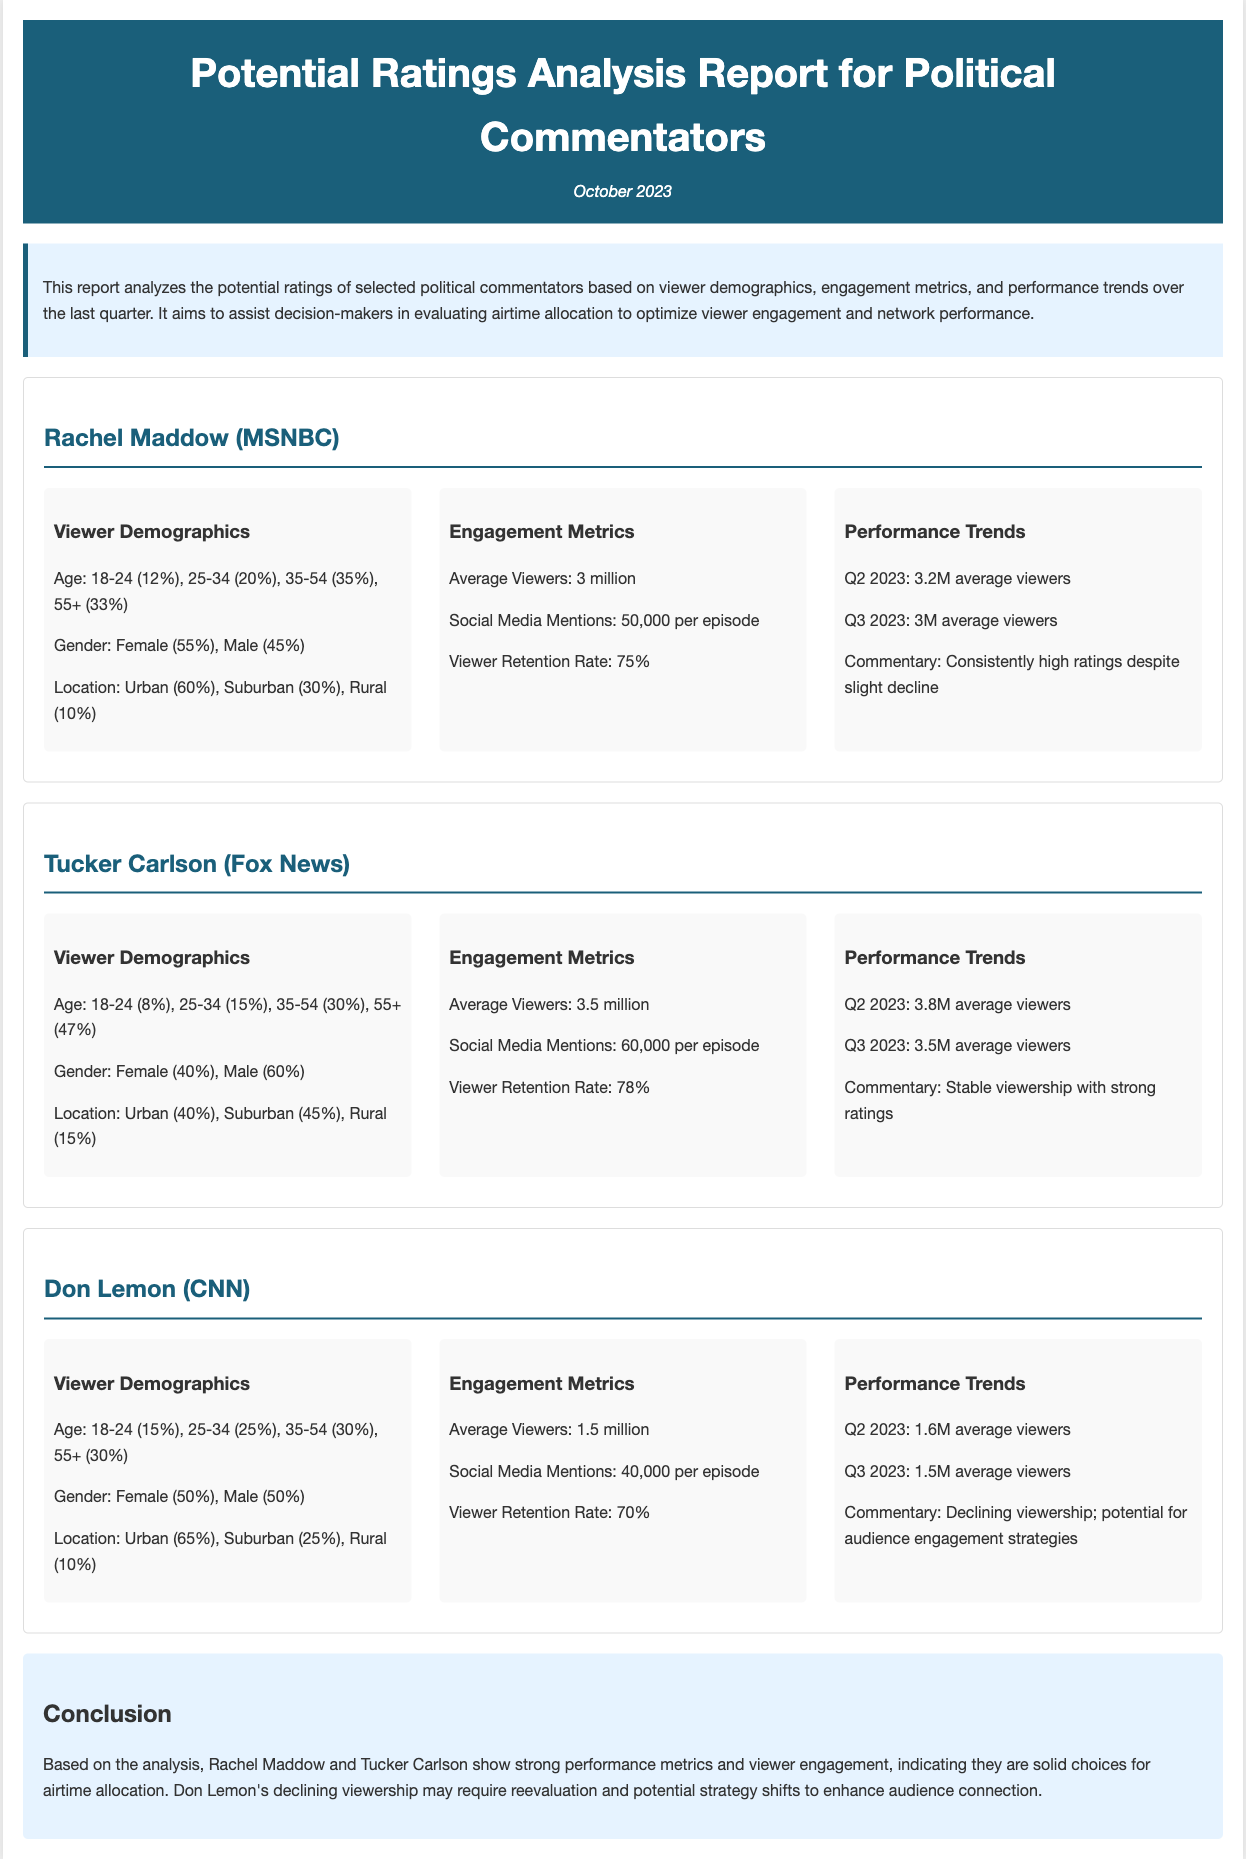What is the average number of viewers for Rachel Maddow? The average number of viewers for Rachel Maddow is provided in the document as 3 million.
Answer: 3 million What percentage of Tucker Carlson's viewers are aged 55 and older? The document states that 47% of Tucker Carlson's viewers are aged 55 and older.
Answer: 47% What is Don Lemon's viewer retention rate? The viewer retention rate for Don Lemon is mentioned in the document as 70%.
Answer: 70% How many social media mentions does Rachel Maddow receive per episode? The document indicates that Rachel Maddow receives 50,000 social media mentions per episode.
Answer: 50,000 What was the average viewers trend for Tucker Carlson from Q2 to Q3 2023? The document shows that Tucker Carlson's average viewers declined from 3.8 million in Q2 to 3.5 million in Q3 2023.
Answer: Decline Which commentator has the highest average viewers? The document states that Tucker Carlson has the highest average viewers at 3.5 million.
Answer: Tucker Carlson What is the main conclusion regarding Don Lemon's performance? The document concludes that Don Lemon's viewership is declining and may require reevaluation.
Answer: Reevaluation How many episodes did Don Lemon's show mention for social media engagement? The document specifies that Don Lemon's social media mentions per episode are 40,000.
Answer: 40,000 What is the date of the report? The report date is mentioned as October 2023.
Answer: October 2023 